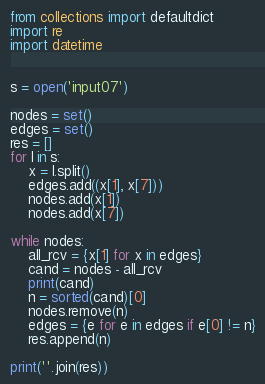<code> <loc_0><loc_0><loc_500><loc_500><_Python_>from collections import defaultdict
import re
import datetime


s = open('input07')

nodes = set()
edges = set()
res = []
for l in s:
    x = l.split()
    edges.add((x[1], x[7]))
    nodes.add(x[1])
    nodes.add(x[7])

while nodes:
    all_rcv = {x[1] for x in edges}
    cand = nodes - all_rcv
    print(cand)
    n = sorted(cand)[0]
    nodes.remove(n)
    edges = {e for e in edges if e[0] != n}
    res.append(n)

print(''.join(res))</code> 